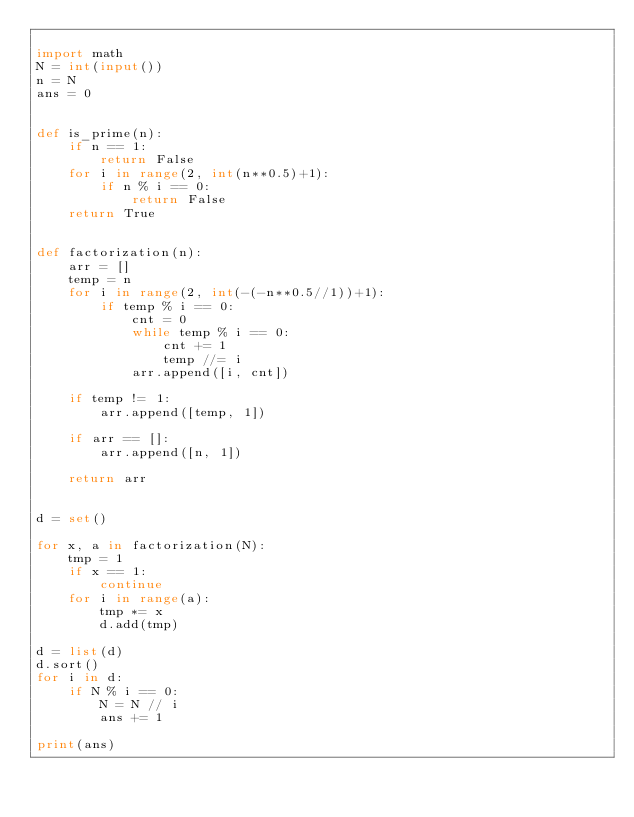<code> <loc_0><loc_0><loc_500><loc_500><_Python_>
import math
N = int(input())
n = N
ans = 0


def is_prime(n):
    if n == 1:
        return False
    for i in range(2, int(n**0.5)+1):
        if n % i == 0:
            return False
    return True


def factorization(n):
    arr = []
    temp = n
    for i in range(2, int(-(-n**0.5//1))+1):
        if temp % i == 0:
            cnt = 0
            while temp % i == 0:
                cnt += 1
                temp //= i
            arr.append([i, cnt])

    if temp != 1:
        arr.append([temp, 1])

    if arr == []:
        arr.append([n, 1])

    return arr


d = set()

for x, a in factorization(N):
    tmp = 1
    if x == 1:
        continue
    for i in range(a):
        tmp *= x
        d.add(tmp)

d = list(d)
d.sort()
for i in d:
    if N % i == 0:
        N = N // i
        ans += 1

print(ans)
</code> 